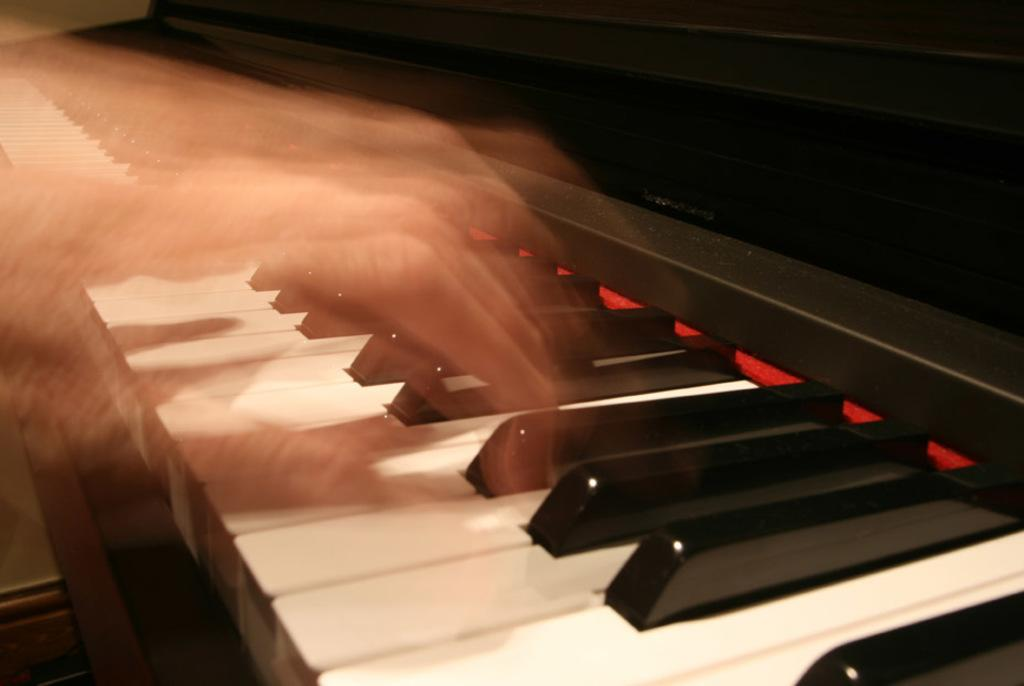What is the main subject of the image? There is a person in the image. What is the person doing in the image? The person is playing a musical instrument. What religion does the cat in the image practice? There is no cat present in the image, and therefore no religion can be associated with it. 